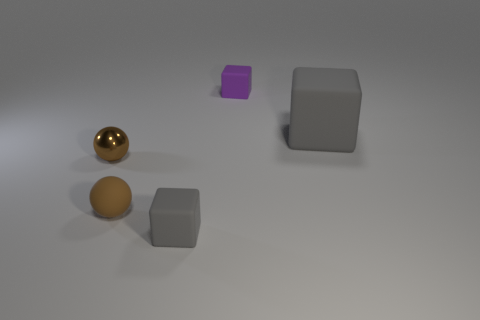Add 3 brown metallic objects. How many objects exist? 8 Subtract all purple cubes. How many cubes are left? 2 Subtract all purple cubes. How many cubes are left? 2 Subtract all cubes. How many objects are left? 2 Subtract all blue balls. Subtract all gray blocks. How many balls are left? 2 Subtract all red balls. How many blue cubes are left? 0 Subtract all cubes. Subtract all large matte objects. How many objects are left? 1 Add 4 big gray rubber things. How many big gray rubber things are left? 5 Add 4 gray shiny cylinders. How many gray shiny cylinders exist? 4 Subtract 0 cyan balls. How many objects are left? 5 